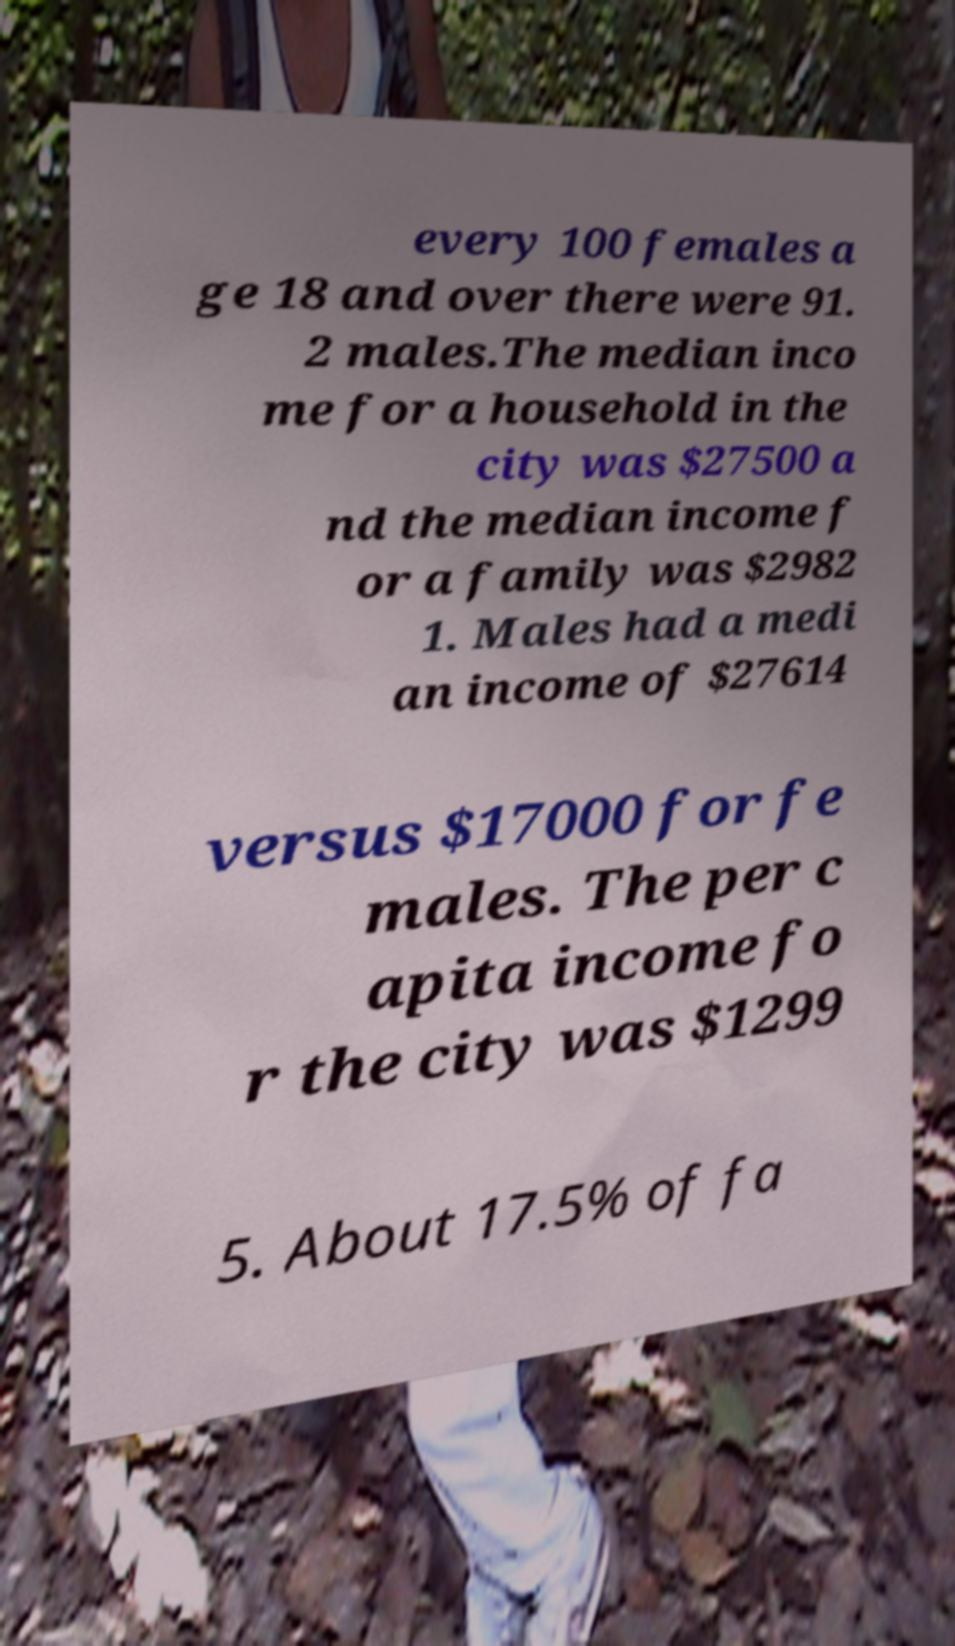Can you read and provide the text displayed in the image?This photo seems to have some interesting text. Can you extract and type it out for me? every 100 females a ge 18 and over there were 91. 2 males.The median inco me for a household in the city was $27500 a nd the median income f or a family was $2982 1. Males had a medi an income of $27614 versus $17000 for fe males. The per c apita income fo r the city was $1299 5. About 17.5% of fa 